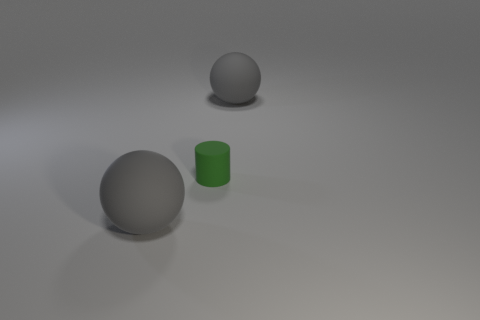Add 2 large gray rubber spheres. How many objects exist? 5 Subtract all brown balls. Subtract all yellow cylinders. How many balls are left? 2 Subtract all balls. How many objects are left? 1 Subtract 0 gray blocks. How many objects are left? 3 Subtract all small green matte cylinders. Subtract all big gray objects. How many objects are left? 0 Add 1 gray matte objects. How many gray matte objects are left? 3 Add 3 big gray rubber objects. How many big gray rubber objects exist? 5 